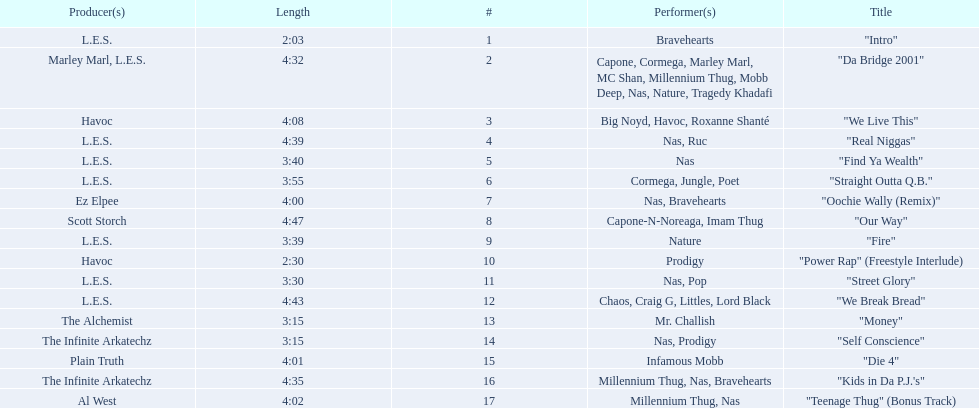What are all the song titles? "Intro", "Da Bridge 2001", "We Live This", "Real Niggas", "Find Ya Wealth", "Straight Outta Q.B.", "Oochie Wally (Remix)", "Our Way", "Fire", "Power Rap" (Freestyle Interlude), "Street Glory", "We Break Bread", "Money", "Self Conscience", "Die 4", "Kids in Da P.J.'s", "Teenage Thug" (Bonus Track). Who produced all these songs? L.E.S., Marley Marl, L.E.S., Ez Elpee, Scott Storch, Havoc, The Alchemist, The Infinite Arkatechz, Plain Truth, Al West. Of the producers, who produced the shortest song? L.E.S. How short was this producer's song? 2:03. 